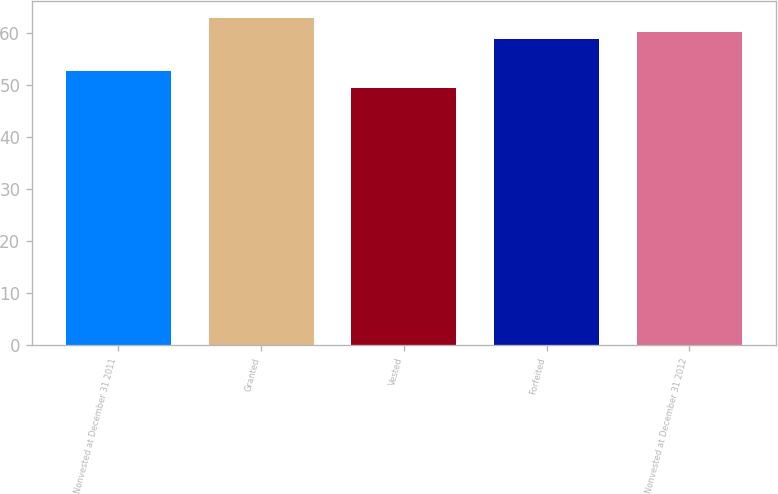Convert chart. <chart><loc_0><loc_0><loc_500><loc_500><bar_chart><fcel>Nonvested at December 31 2011<fcel>Granted<fcel>Vested<fcel>Forfeited<fcel>Nonvested at December 31 2012<nl><fcel>52.72<fcel>63.07<fcel>49.42<fcel>58.93<fcel>60.3<nl></chart> 